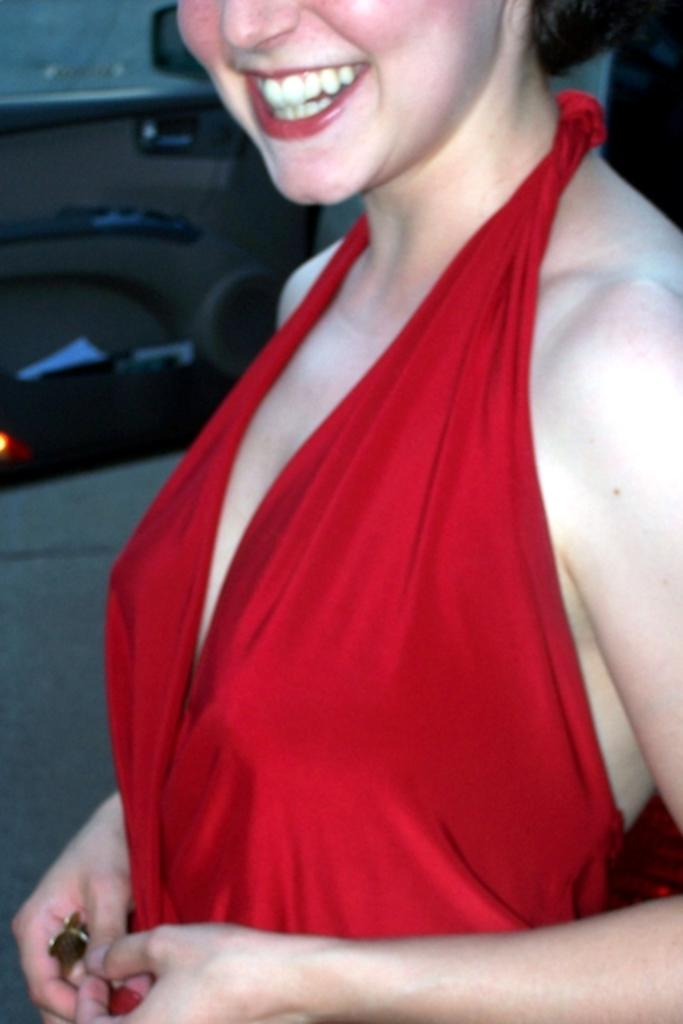Who is the main subject in the image? There is a woman in the image. What is the woman wearing? The woman is wearing a red dress. What is the woman's facial expression? The woman is smiling. What is the woman's posture in the image? The woman is standing. What else can be seen in the image besides the woman? There are other objects in the background of the image. Can you see a frog hopping in the image? No, there is no frog present in the image. 